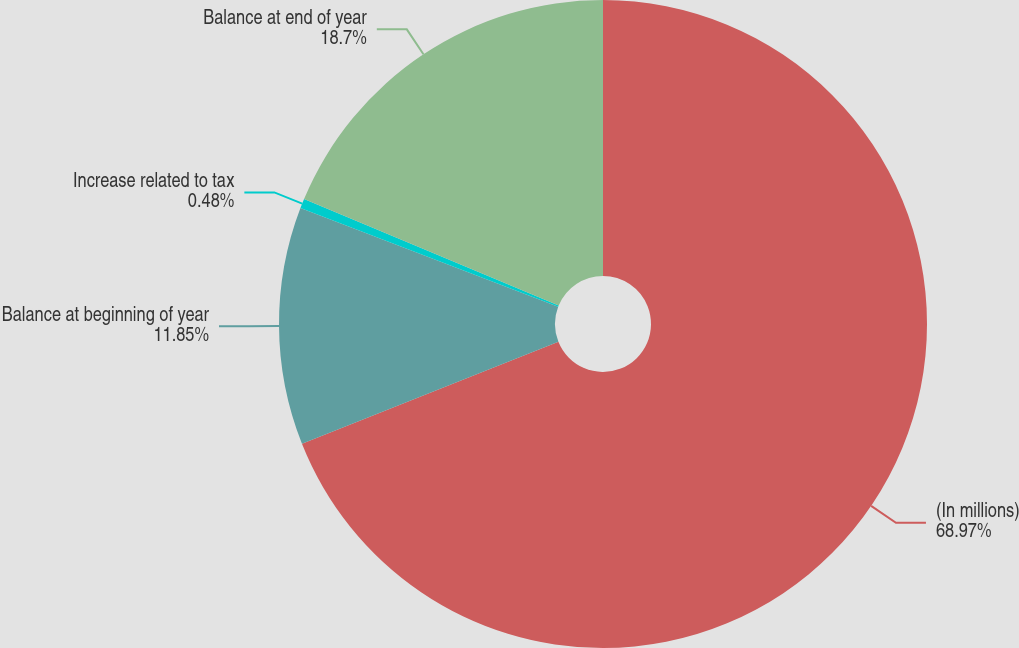Convert chart. <chart><loc_0><loc_0><loc_500><loc_500><pie_chart><fcel>(In millions)<fcel>Balance at beginning of year<fcel>Increase related to tax<fcel>Balance at end of year<nl><fcel>68.98%<fcel>11.85%<fcel>0.48%<fcel>18.7%<nl></chart> 